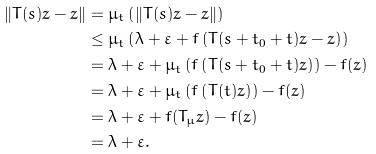<formula> <loc_0><loc_0><loc_500><loc_500>\| T ( s ) z - z \| & = \mu _ { t } \left ( \| T ( s ) z - z \| \right ) \\ & \leq \mu _ { t } \left ( \lambda + \varepsilon + f \left ( T ( s + t _ { 0 } + t ) z - z \right ) \right ) \\ & = \lambda + \varepsilon + \mu _ { t } \left ( f \left ( T ( s + t _ { 0 } + t ) z \right ) \right ) - f ( z ) \\ & = \lambda + \varepsilon + \mu _ { t } \left ( f \left ( T ( t ) z \right ) \right ) - f ( z ) \\ & = \lambda + \varepsilon + f ( T _ { \mu } z ) - f ( z ) \\ & = \lambda + \varepsilon .</formula> 